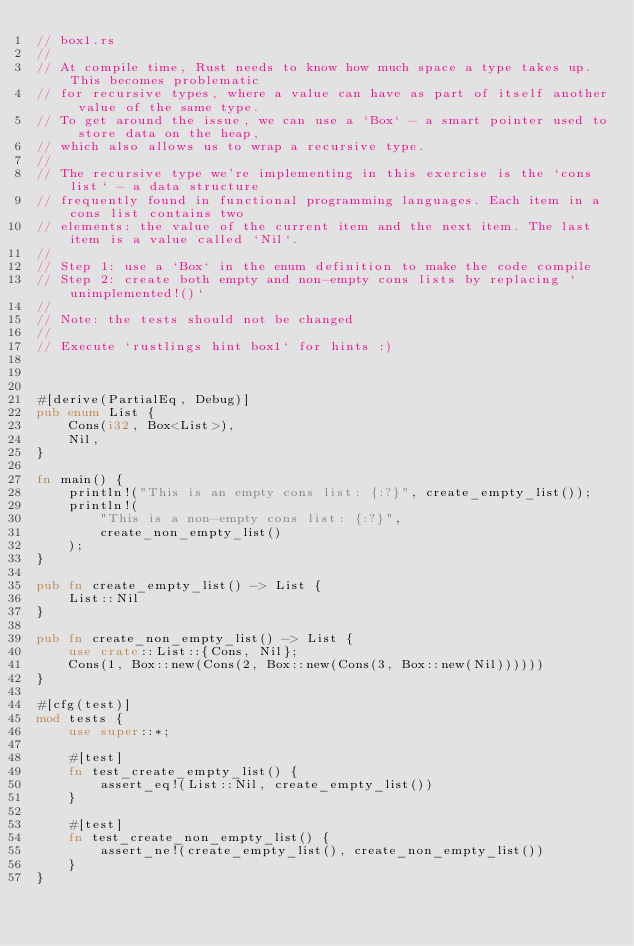Convert code to text. <code><loc_0><loc_0><loc_500><loc_500><_Rust_>// box1.rs
//
// At compile time, Rust needs to know how much space a type takes up. This becomes problematic
// for recursive types, where a value can have as part of itself another value of the same type.
// To get around the issue, we can use a `Box` - a smart pointer used to store data on the heap,
// which also allows us to wrap a recursive type.
//
// The recursive type we're implementing in this exercise is the `cons list` - a data structure
// frequently found in functional programming languages. Each item in a cons list contains two
// elements: the value of the current item and the next item. The last item is a value called `Nil`.
//
// Step 1: use a `Box` in the enum definition to make the code compile
// Step 2: create both empty and non-empty cons lists by replacing `unimplemented!()`
//
// Note: the tests should not be changed
//
// Execute `rustlings hint box1` for hints :)



#[derive(PartialEq, Debug)]
pub enum List {
    Cons(i32, Box<List>),
    Nil,
}

fn main() {
    println!("This is an empty cons list: {:?}", create_empty_list());
    println!(
        "This is a non-empty cons list: {:?}",
        create_non_empty_list()
    );
}

pub fn create_empty_list() -> List {
    List::Nil
}

pub fn create_non_empty_list() -> List {
    use crate::List::{Cons, Nil};
    Cons(1, Box::new(Cons(2, Box::new(Cons(3, Box::new(Nil))))))
}

#[cfg(test)]
mod tests {
    use super::*;

    #[test]
    fn test_create_empty_list() {
        assert_eq!(List::Nil, create_empty_list())
    }

    #[test]
    fn test_create_non_empty_list() {
        assert_ne!(create_empty_list(), create_non_empty_list())
    }
}
</code> 